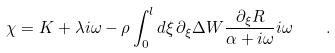Convert formula to latex. <formula><loc_0><loc_0><loc_500><loc_500>\chi = K + \lambda i \omega - \rho \int _ { 0 } ^ { l } d \xi \, \partial _ { \xi } \Delta W \frac { \partial _ { \xi } R } { \alpha + i \omega } i \omega \quad .</formula> 